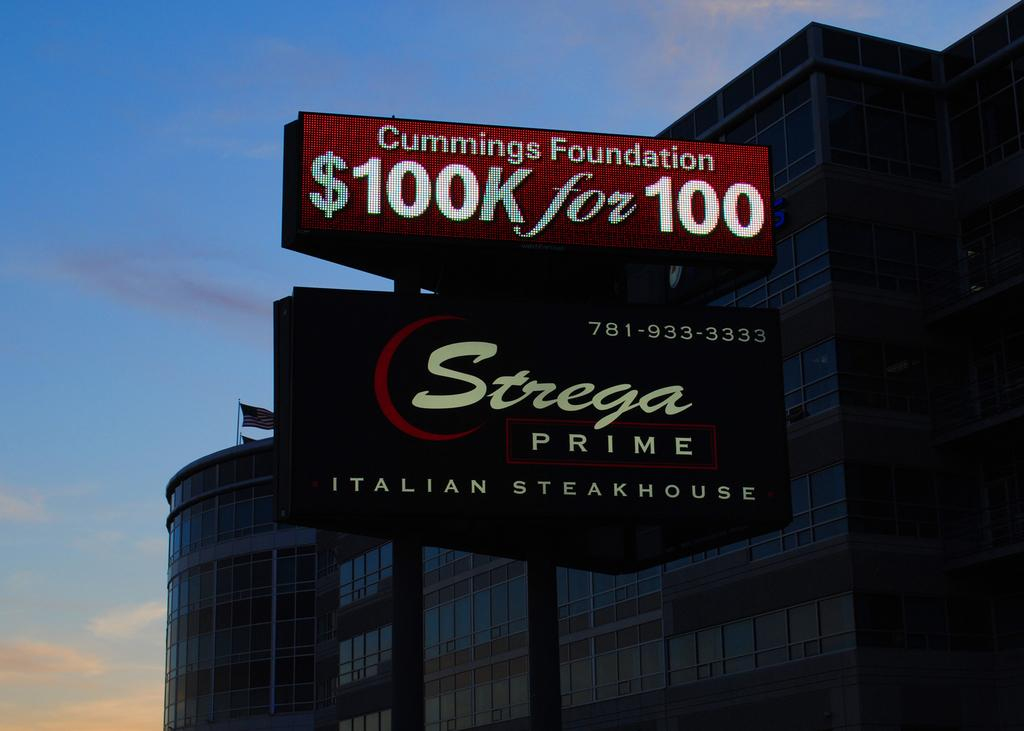<image>
Render a clear and concise summary of the photo. A sign for an Italian steakhouse also advertises Cummings Foundation above. 